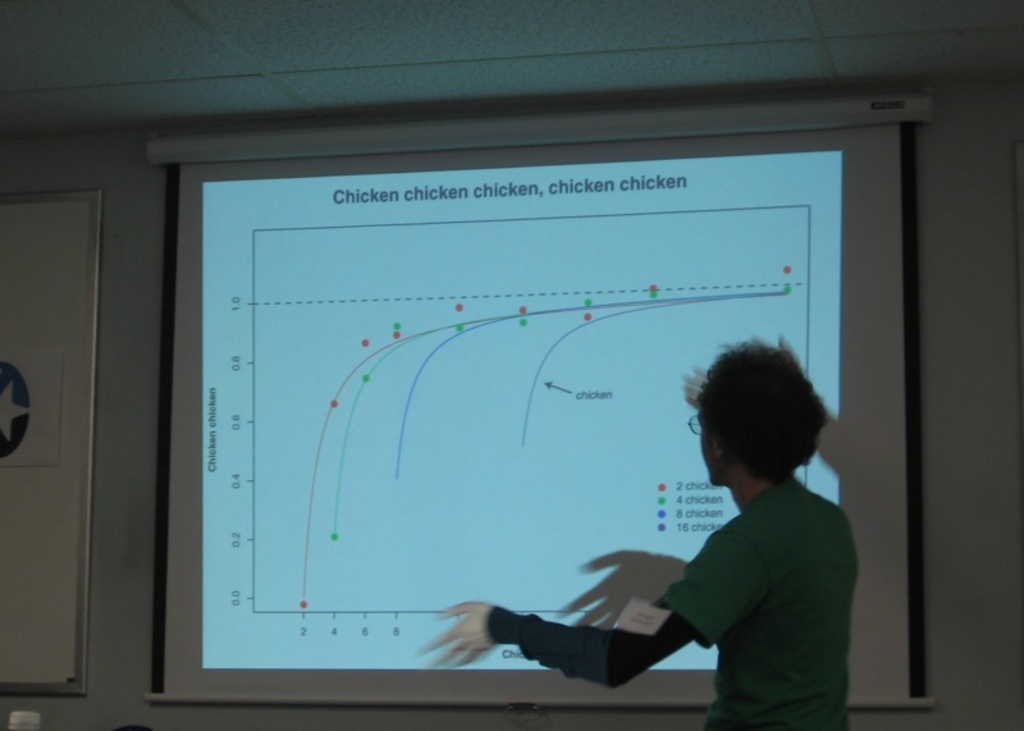How does the audience usually react to such a presentation? The audience typically responds with amusement and curiosity, often resulting in a lighthearted discussion on the creative presentation of otherwise mundane data. 